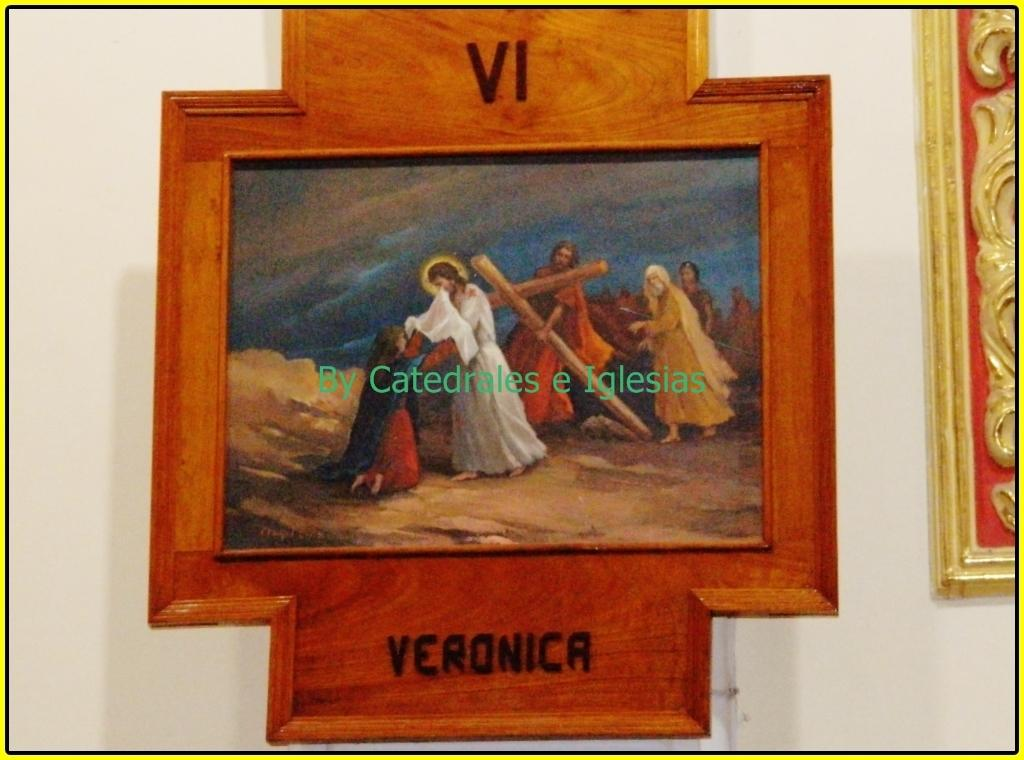<image>
Provide a brief description of the given image. A religious painting that has the name Veronica and a roman numeral for six on it. 